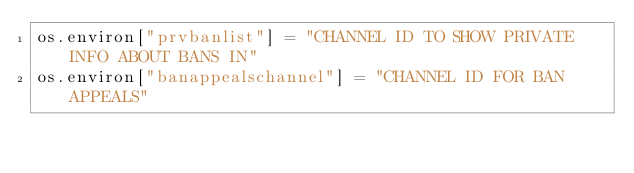Convert code to text. <code><loc_0><loc_0><loc_500><loc_500><_Python_>os.environ["prvbanlist"] = "CHANNEL ID TO SHOW PRIVATE INFO ABOUT BANS IN"
os.environ["banappealschannel"] = "CHANNEL ID FOR BAN APPEALS"
</code> 